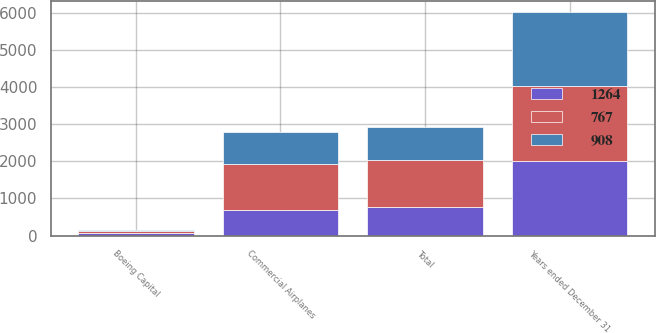Convert chart to OTSL. <chart><loc_0><loc_0><loc_500><loc_500><stacked_bar_chart><ecel><fcel>Years ended December 31<fcel>Commercial Airplanes<fcel>Boeing Capital<fcel>Total<nl><fcel>908<fcel>2013<fcel>879<fcel>29<fcel>908<nl><fcel>767<fcel>2012<fcel>1215<fcel>49<fcel>1264<nl><fcel>1264<fcel>2011<fcel>701<fcel>66<fcel>767<nl></chart> 